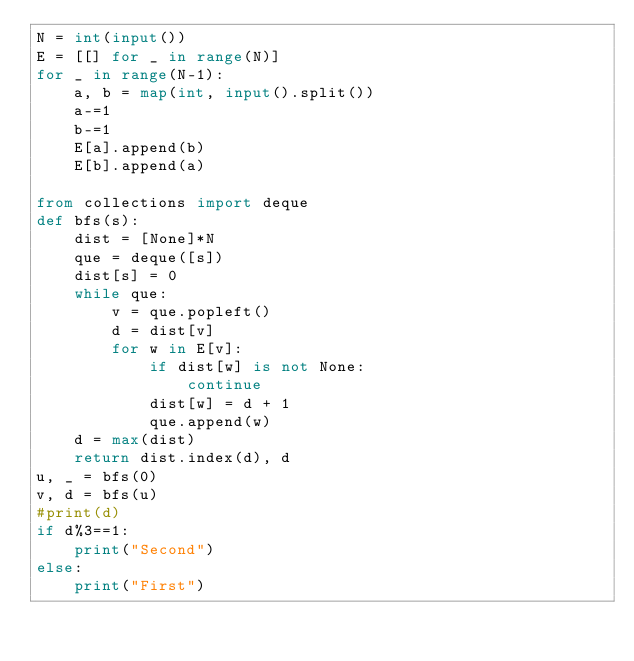<code> <loc_0><loc_0><loc_500><loc_500><_Python_>N = int(input())
E = [[] for _ in range(N)]
for _ in range(N-1):
    a, b = map(int, input().split())
    a-=1
    b-=1
    E[a].append(b)
    E[b].append(a)

from collections import deque
def bfs(s):
    dist = [None]*N
    que = deque([s])
    dist[s] = 0
    while que:
        v = que.popleft()
        d = dist[v]
        for w in E[v]:
            if dist[w] is not None:
                continue
            dist[w] = d + 1
            que.append(w)
    d = max(dist)
    return dist.index(d), d
u, _ = bfs(0)
v, d = bfs(u)
#print(d)
if d%3==1:
    print("Second")
else:
    print("First")
</code> 